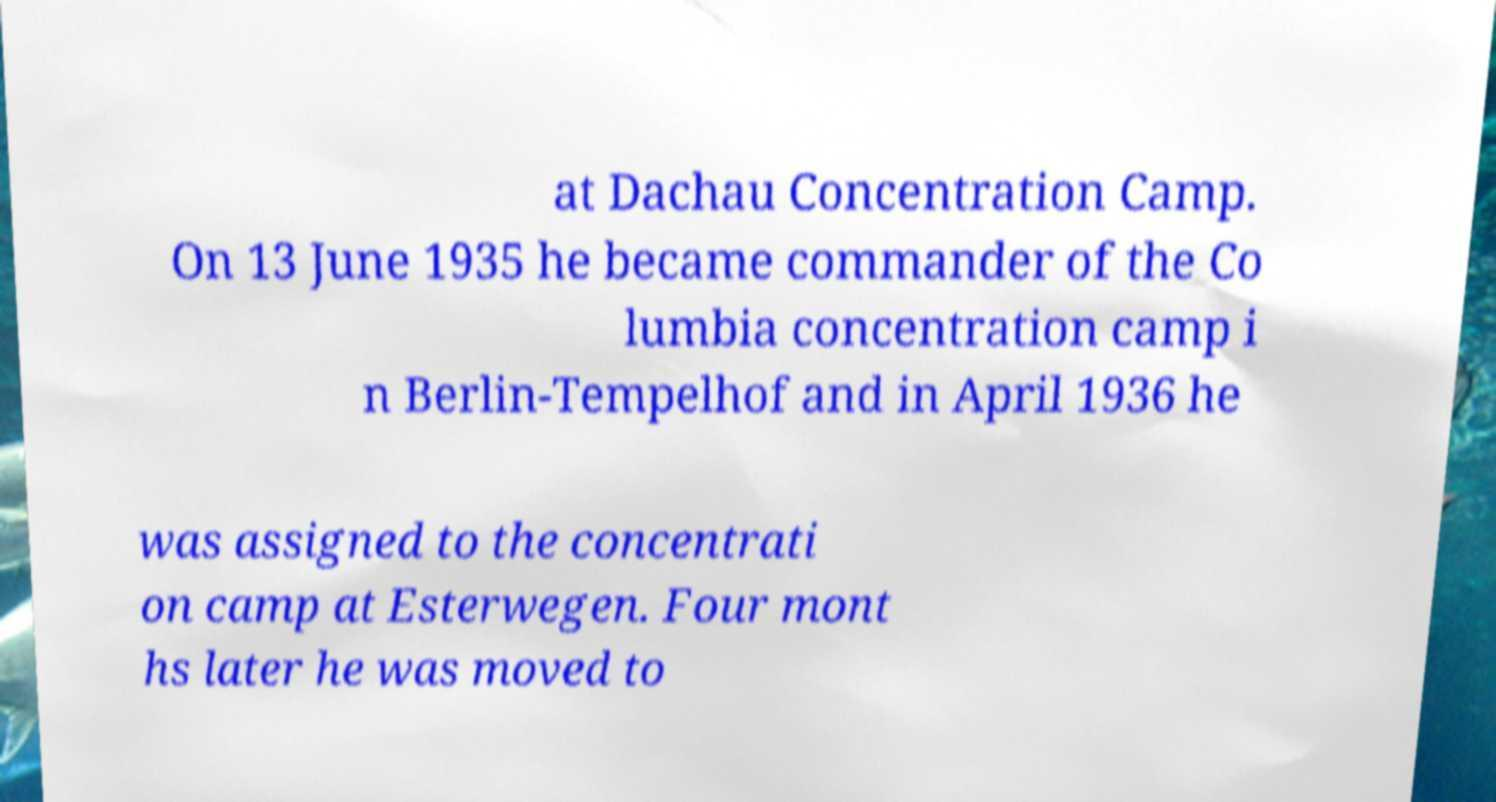Could you extract and type out the text from this image? at Dachau Concentration Camp. On 13 June 1935 he became commander of the Co lumbia concentration camp i n Berlin-Tempelhof and in April 1936 he was assigned to the concentrati on camp at Esterwegen. Four mont hs later he was moved to 